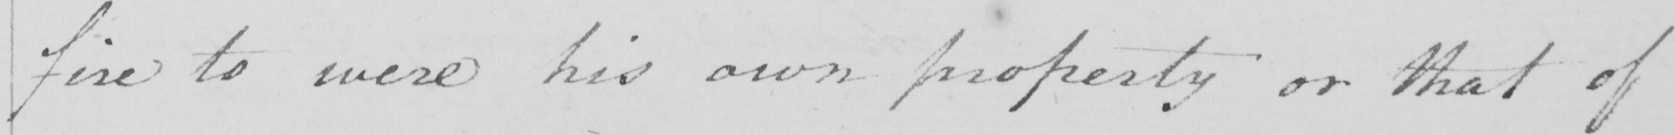Can you read and transcribe this handwriting? fire to were his own property or that of 